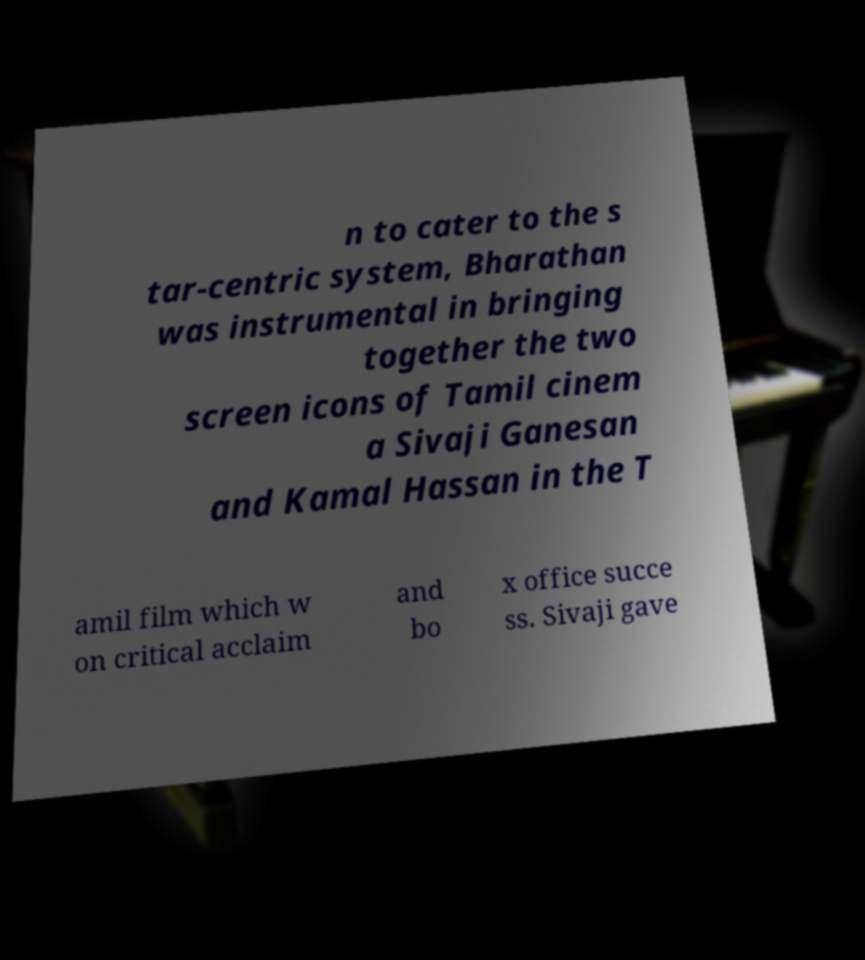Can you read and provide the text displayed in the image?This photo seems to have some interesting text. Can you extract and type it out for me? n to cater to the s tar-centric system, Bharathan was instrumental in bringing together the two screen icons of Tamil cinem a Sivaji Ganesan and Kamal Hassan in the T amil film which w on critical acclaim and bo x office succe ss. Sivaji gave 